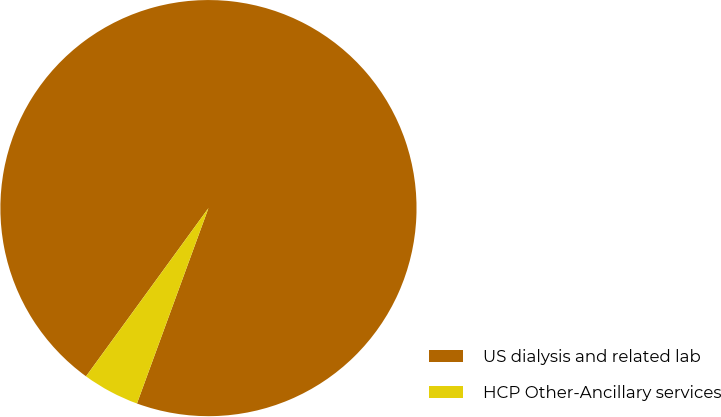<chart> <loc_0><loc_0><loc_500><loc_500><pie_chart><fcel>US dialysis and related lab<fcel>HCP Other-Ancillary services<nl><fcel>95.57%<fcel>4.43%<nl></chart> 